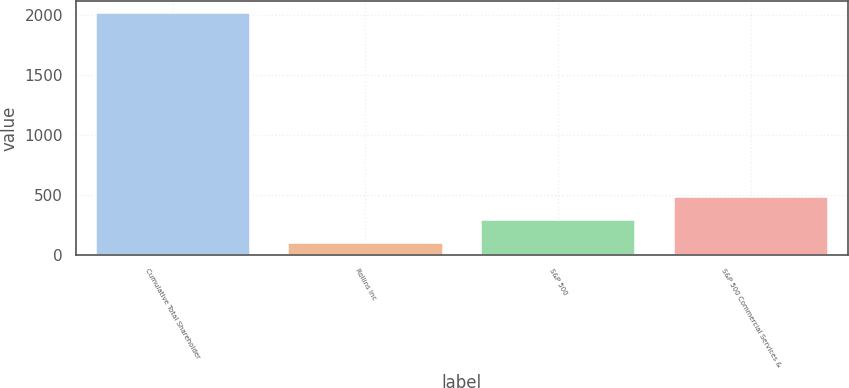Convert chart to OTSL. <chart><loc_0><loc_0><loc_500><loc_500><bar_chart><fcel>Cumulative Total Shareholder<fcel>Rollins Inc<fcel>S&P 500<fcel>S&P 500 Commercial Services &<nl><fcel>2013<fcel>100<fcel>291.3<fcel>482.6<nl></chart> 